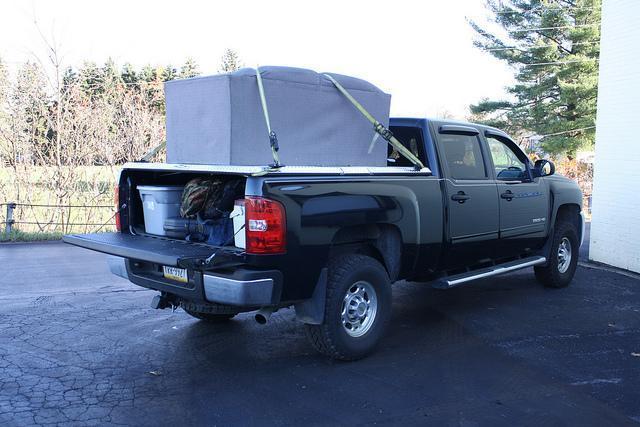Is the given caption "The truck contains the couch." fitting for the image?
Answer yes or no. Yes. Is the caption "The couch is under the truck." a true representation of the image?
Answer yes or no. No. Is the caption "The truck is opposite to the couch." a true representation of the image?
Answer yes or no. No. Does the caption "The truck is on the couch." correctly depict the image?
Answer yes or no. No. Does the image validate the caption "The couch is on the truck."?
Answer yes or no. Yes. 